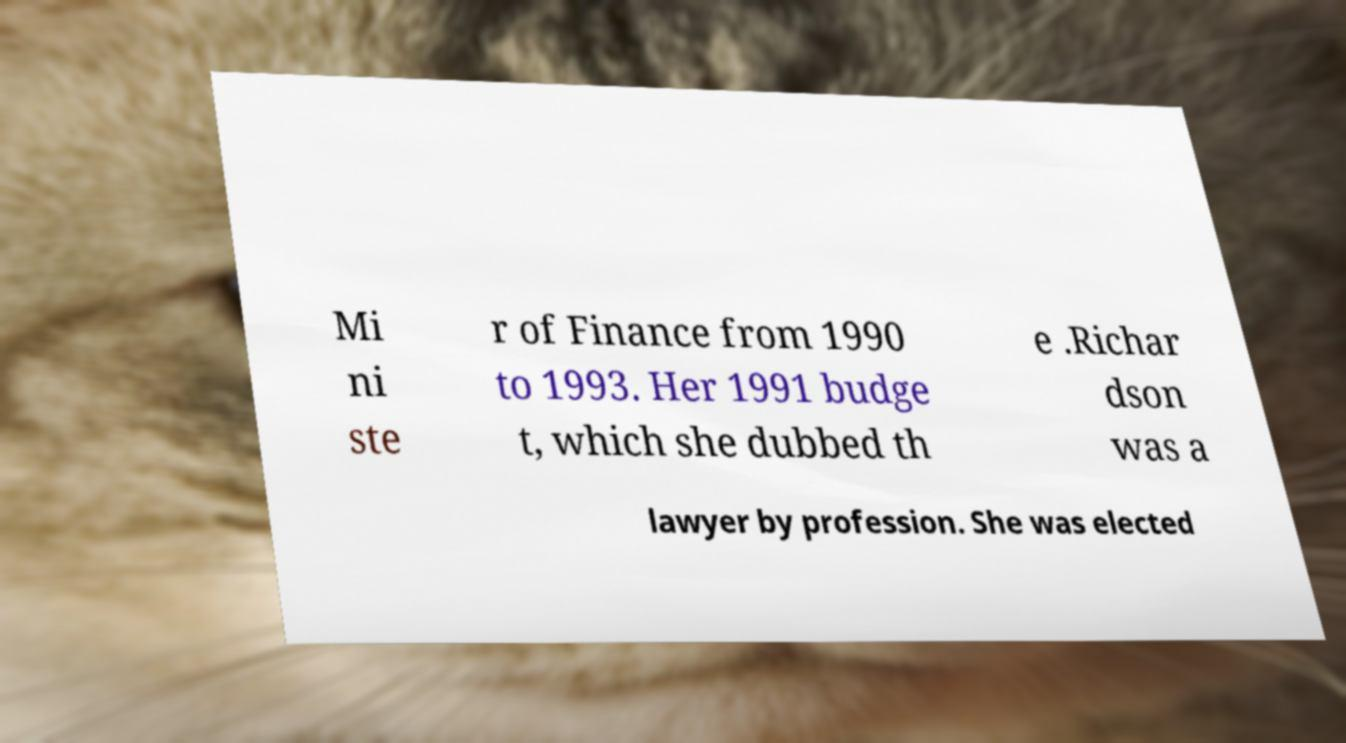For documentation purposes, I need the text within this image transcribed. Could you provide that? Mi ni ste r of Finance from 1990 to 1993. Her 1991 budge t, which she dubbed th e .Richar dson was a lawyer by profession. She was elected 